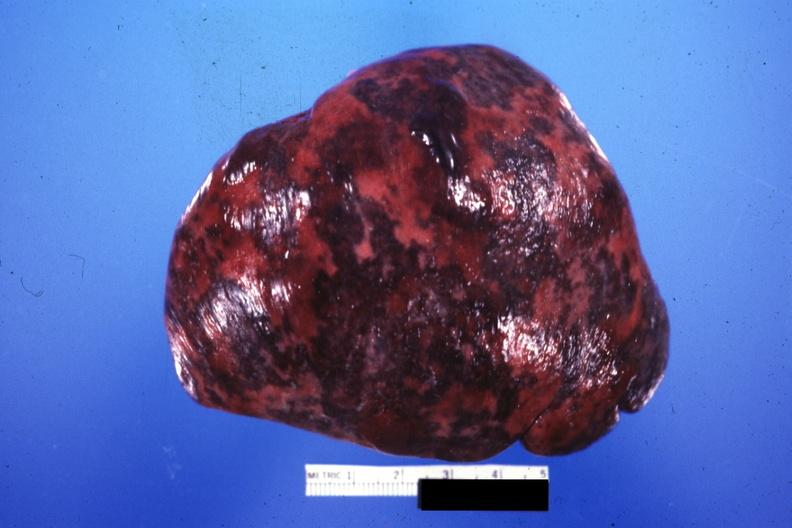what is present?
Answer the question using a single word or phrase. Spleen 